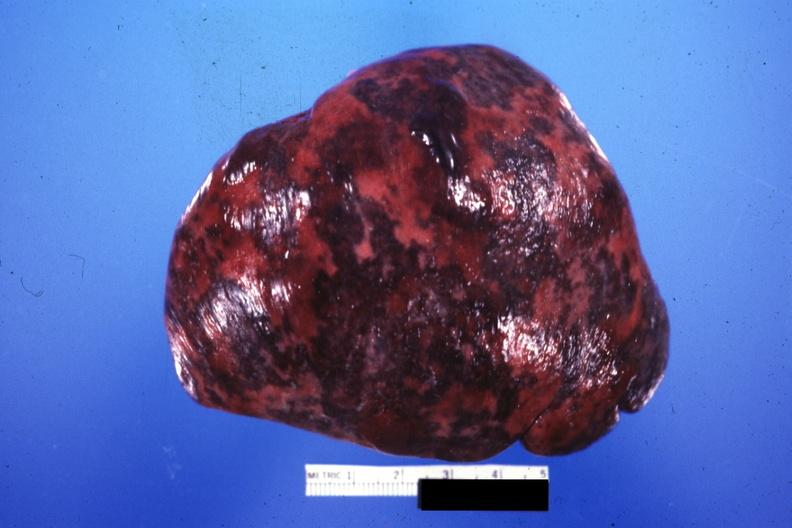what is present?
Answer the question using a single word or phrase. Spleen 